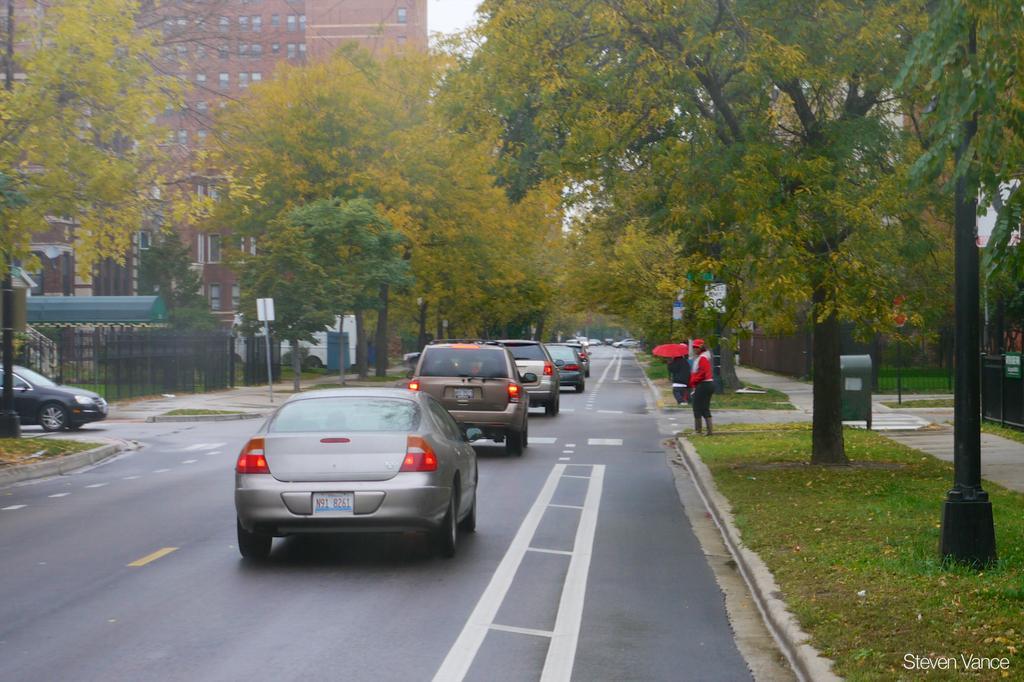How would you summarize this image in a sentence or two? In this image we can see the vehicles passing on the road. We can also see the person's, umbrella, boards, trash bin and also the trees. We can also see the grass and also the building. We can also see the sky and also the fence. 